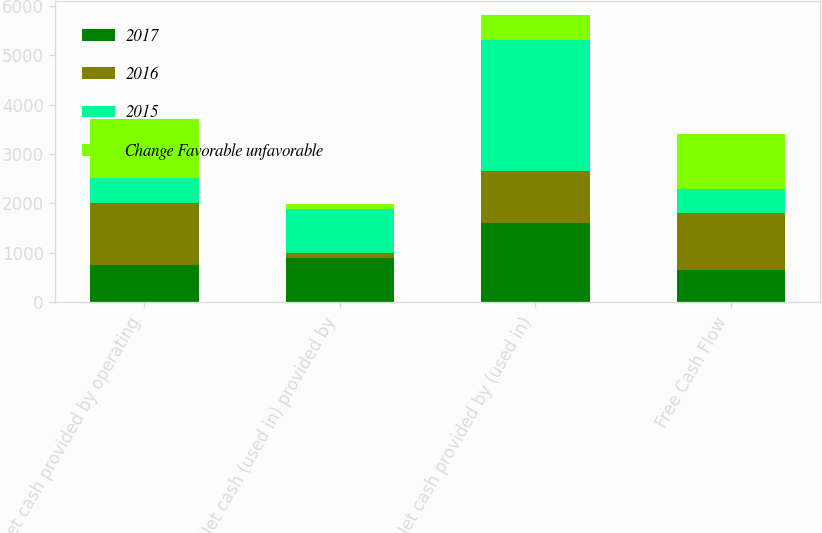<chart> <loc_0><loc_0><loc_500><loc_500><stacked_bar_chart><ecel><fcel>Net cash provided by operating<fcel>Net cash (used in) provided by<fcel>Net cash provided by (used in)<fcel>Free Cash Flow<nl><fcel>2017<fcel>747.5<fcel>895.2<fcel>1607.2<fcel>656.9<nl><fcel>2016<fcel>1259.2<fcel>102<fcel>1042.9<fcel>1144<nl><fcel>2015<fcel>511.7<fcel>895.2<fcel>2650.1<fcel>487.1<nl><fcel>Change Favorable unfavorable<fcel>1198.1<fcel>92<fcel>505.5<fcel>1109.1<nl></chart> 